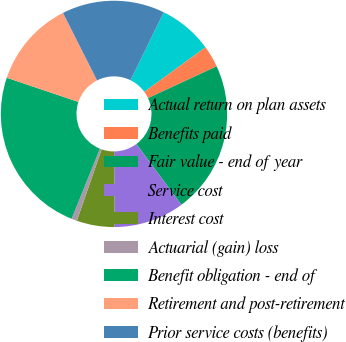<chart> <loc_0><loc_0><loc_500><loc_500><pie_chart><fcel>Actual return on plan assets<fcel>Benefits paid<fcel>Fair value - end of year<fcel>Service cost<fcel>Interest cost<fcel>Actuarial (gain) loss<fcel>Benefit obligation - end of<fcel>Retirement and post-retirement<fcel>Prior service costs (benefits)<nl><fcel>7.74%<fcel>3.11%<fcel>21.74%<fcel>10.06%<fcel>5.42%<fcel>0.79%<fcel>24.06%<fcel>12.38%<fcel>14.69%<nl></chart> 